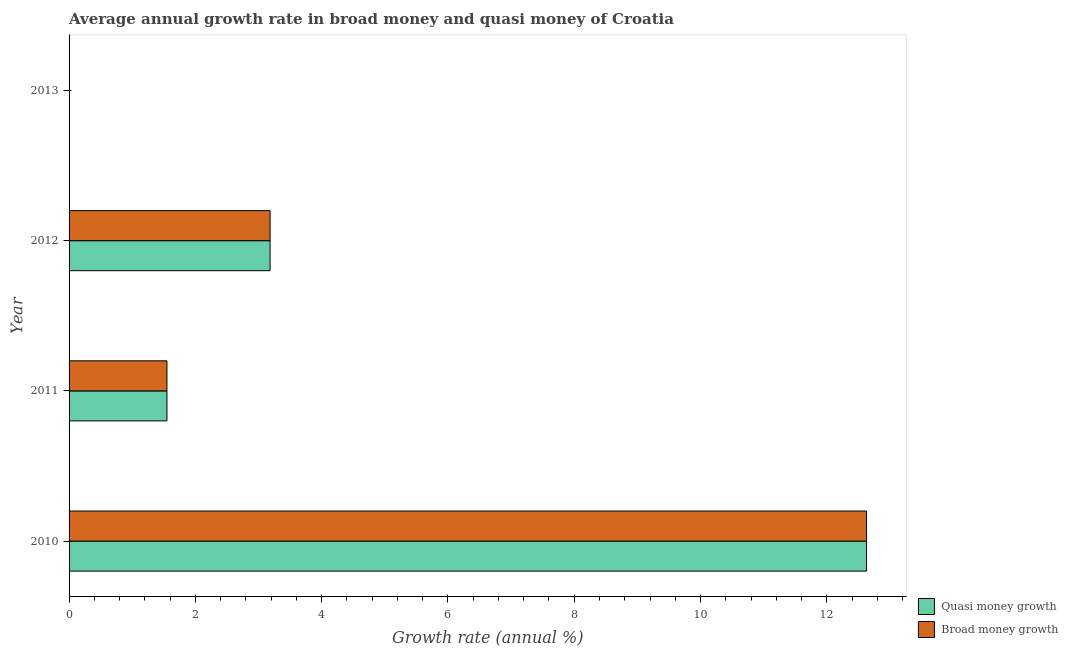How many different coloured bars are there?
Keep it short and to the point. 2. Are the number of bars per tick equal to the number of legend labels?
Your answer should be very brief. No. Are the number of bars on each tick of the Y-axis equal?
Keep it short and to the point. No. What is the label of the 2nd group of bars from the top?
Offer a terse response. 2012. In how many cases, is the number of bars for a given year not equal to the number of legend labels?
Your response must be concise. 1. What is the annual growth rate in quasi money in 2011?
Keep it short and to the point. 1.55. Across all years, what is the maximum annual growth rate in quasi money?
Give a very brief answer. 12.63. What is the total annual growth rate in quasi money in the graph?
Make the answer very short. 17.36. What is the difference between the annual growth rate in broad money in 2010 and that in 2012?
Your answer should be very brief. 9.45. What is the difference between the annual growth rate in broad money in 2011 and the annual growth rate in quasi money in 2013?
Your answer should be very brief. 1.55. What is the average annual growth rate in quasi money per year?
Provide a short and direct response. 4.34. In the year 2012, what is the difference between the annual growth rate in quasi money and annual growth rate in broad money?
Offer a very short reply. 0. What is the ratio of the annual growth rate in quasi money in 2010 to that in 2012?
Ensure brevity in your answer.  3.97. Is the annual growth rate in broad money in 2010 less than that in 2012?
Keep it short and to the point. No. What is the difference between the highest and the second highest annual growth rate in broad money?
Your answer should be compact. 9.45. What is the difference between the highest and the lowest annual growth rate in broad money?
Offer a very short reply. 12.63. In how many years, is the annual growth rate in broad money greater than the average annual growth rate in broad money taken over all years?
Provide a short and direct response. 1. Is the sum of the annual growth rate in broad money in 2010 and 2012 greater than the maximum annual growth rate in quasi money across all years?
Offer a terse response. Yes. How many years are there in the graph?
Your response must be concise. 4. How are the legend labels stacked?
Ensure brevity in your answer.  Vertical. What is the title of the graph?
Provide a succinct answer. Average annual growth rate in broad money and quasi money of Croatia. Does "Methane" appear as one of the legend labels in the graph?
Make the answer very short. No. What is the label or title of the X-axis?
Provide a short and direct response. Growth rate (annual %). What is the Growth rate (annual %) in Quasi money growth in 2010?
Your answer should be compact. 12.63. What is the Growth rate (annual %) in Broad money growth in 2010?
Ensure brevity in your answer.  12.63. What is the Growth rate (annual %) of Quasi money growth in 2011?
Give a very brief answer. 1.55. What is the Growth rate (annual %) in Broad money growth in 2011?
Ensure brevity in your answer.  1.55. What is the Growth rate (annual %) in Quasi money growth in 2012?
Offer a very short reply. 3.18. What is the Growth rate (annual %) of Broad money growth in 2012?
Offer a terse response. 3.18. What is the Growth rate (annual %) in Quasi money growth in 2013?
Keep it short and to the point. 0. What is the Growth rate (annual %) of Broad money growth in 2013?
Offer a terse response. 0. Across all years, what is the maximum Growth rate (annual %) in Quasi money growth?
Give a very brief answer. 12.63. Across all years, what is the maximum Growth rate (annual %) in Broad money growth?
Offer a very short reply. 12.63. Across all years, what is the minimum Growth rate (annual %) in Quasi money growth?
Provide a short and direct response. 0. Across all years, what is the minimum Growth rate (annual %) in Broad money growth?
Your answer should be very brief. 0. What is the total Growth rate (annual %) in Quasi money growth in the graph?
Ensure brevity in your answer.  17.36. What is the total Growth rate (annual %) in Broad money growth in the graph?
Your response must be concise. 17.36. What is the difference between the Growth rate (annual %) of Quasi money growth in 2010 and that in 2011?
Provide a short and direct response. 11.08. What is the difference between the Growth rate (annual %) of Broad money growth in 2010 and that in 2011?
Provide a short and direct response. 11.08. What is the difference between the Growth rate (annual %) in Quasi money growth in 2010 and that in 2012?
Provide a succinct answer. 9.45. What is the difference between the Growth rate (annual %) in Broad money growth in 2010 and that in 2012?
Provide a short and direct response. 9.45. What is the difference between the Growth rate (annual %) of Quasi money growth in 2011 and that in 2012?
Offer a very short reply. -1.63. What is the difference between the Growth rate (annual %) of Broad money growth in 2011 and that in 2012?
Provide a succinct answer. -1.63. What is the difference between the Growth rate (annual %) of Quasi money growth in 2010 and the Growth rate (annual %) of Broad money growth in 2011?
Provide a succinct answer. 11.08. What is the difference between the Growth rate (annual %) of Quasi money growth in 2010 and the Growth rate (annual %) of Broad money growth in 2012?
Provide a short and direct response. 9.45. What is the difference between the Growth rate (annual %) of Quasi money growth in 2011 and the Growth rate (annual %) of Broad money growth in 2012?
Offer a terse response. -1.63. What is the average Growth rate (annual %) in Quasi money growth per year?
Offer a terse response. 4.34. What is the average Growth rate (annual %) of Broad money growth per year?
Provide a succinct answer. 4.34. In the year 2010, what is the difference between the Growth rate (annual %) of Quasi money growth and Growth rate (annual %) of Broad money growth?
Make the answer very short. 0. In the year 2012, what is the difference between the Growth rate (annual %) of Quasi money growth and Growth rate (annual %) of Broad money growth?
Offer a terse response. 0. What is the ratio of the Growth rate (annual %) of Quasi money growth in 2010 to that in 2011?
Ensure brevity in your answer.  8.15. What is the ratio of the Growth rate (annual %) of Broad money growth in 2010 to that in 2011?
Your answer should be very brief. 8.15. What is the ratio of the Growth rate (annual %) in Quasi money growth in 2010 to that in 2012?
Provide a short and direct response. 3.97. What is the ratio of the Growth rate (annual %) in Broad money growth in 2010 to that in 2012?
Your answer should be very brief. 3.97. What is the ratio of the Growth rate (annual %) in Quasi money growth in 2011 to that in 2012?
Ensure brevity in your answer.  0.49. What is the ratio of the Growth rate (annual %) of Broad money growth in 2011 to that in 2012?
Ensure brevity in your answer.  0.49. What is the difference between the highest and the second highest Growth rate (annual %) of Quasi money growth?
Your answer should be very brief. 9.45. What is the difference between the highest and the second highest Growth rate (annual %) of Broad money growth?
Give a very brief answer. 9.45. What is the difference between the highest and the lowest Growth rate (annual %) of Quasi money growth?
Your response must be concise. 12.63. What is the difference between the highest and the lowest Growth rate (annual %) of Broad money growth?
Make the answer very short. 12.63. 